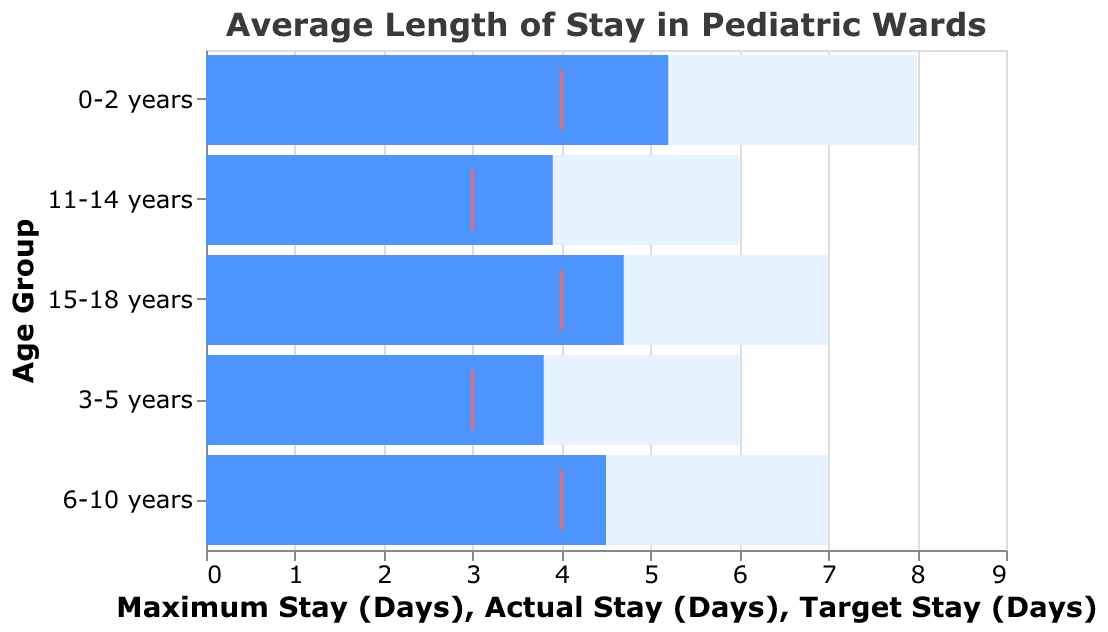What is the title of the chart? The title of the chart is displayed at the top of the figure.
Answer: Average Length of Stay in Pediatric Wards What is the actual average length of stay for the 0-2 years age group? The actual stay is indicated by the blue bar for the 0-2 years age group.
Answer: 5.2 days Which age group has the highest maximum stay? The maximum stay is represented by the light blue bar. By comparing the lengths, the 0-2 years age group has the highest maximum stay.
Answer: 0-2 years What does the red tick mark represent? The red tick mark represents the target stay for each age group.
Answer: Target Stay (Days) Is the actual stay for the 15-18 years age group above or below the target stay? The actual stay is shown by the blue bar, while the target stay is indicated by the red tick mark. For the 15-18 years age group, the blue bar extends beyond the red tick mark.
Answer: Above How does the actual stay for the 3-5 years age group compare to the target stay? Compare the length of the blue bar (actual stay) with the position of the red tick mark (target stay). The actual stay (3.8 days) is above the target stay (3 days).
Answer: Above Which age group has the smallest difference between actual stay and maximum stay? Calculate the difference between the lengths of the light blue bar (maximum stay) and the blue bar (actual stay) for each age group. The 11-14 years age group has the smallest difference (6 - 3.9 = 2.1 days).
Answer: 11-14 years What is the average of the target stays? Summing the target stays: 4 + 3 + 4 + 3 + 4. The sum is 18. There are 5 age groups, so the average is 18/5 = 3.6 days.
Answer: 3.6 days Which age groups have an actual stay equal to their target stay? Compare the blue bar lengths (actual stay) with the red tick marks (target stay) for each age group. No age group has an actual stay exactly equal to their target stay.
Answer: None For the 6-10 years age group, is the actual stay closer to the target stay or the maximum stay? The actual stay (blue bar) for the 6-10 years age group is 4.5 days, the target stay (red tick) is 4 days, and the maximum stay (light blue bar) is 7 days. Calculate the differences:
Answer: Closer to the Target Stay 